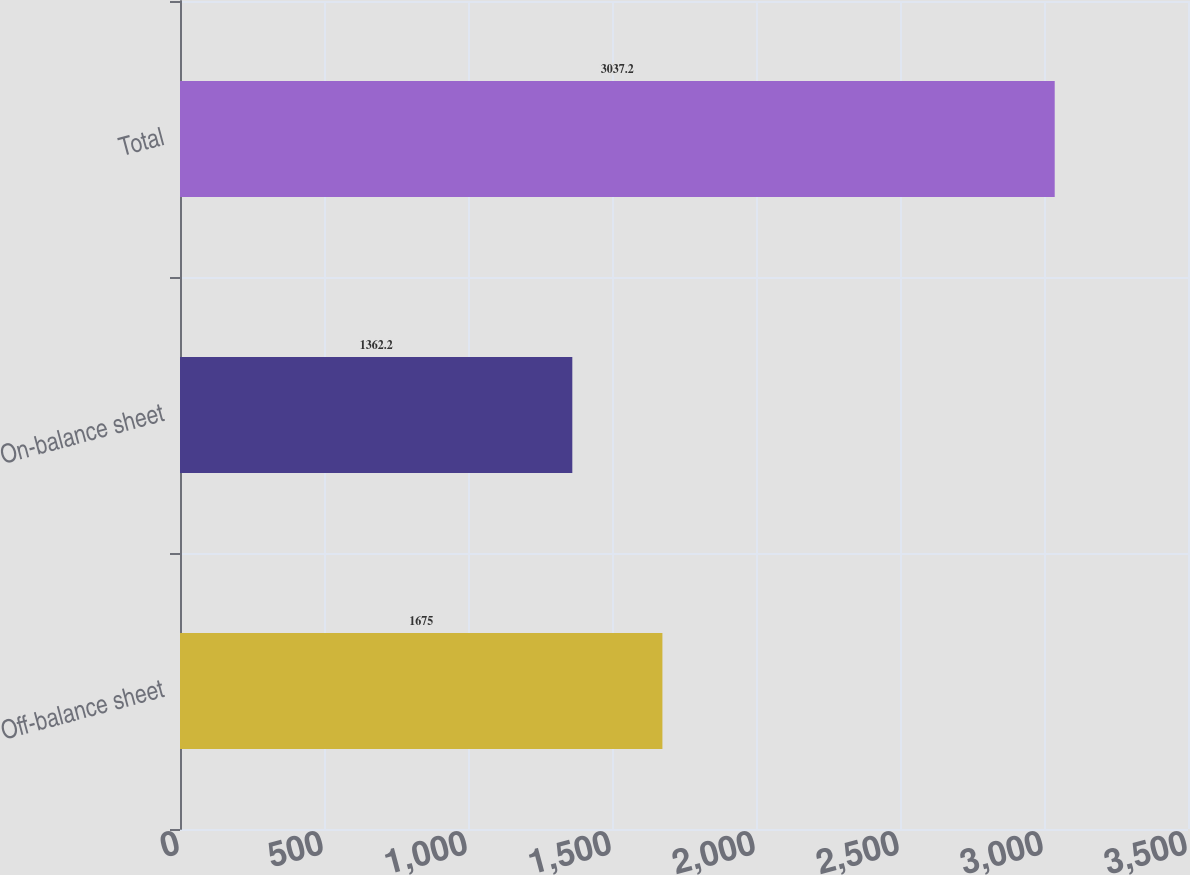<chart> <loc_0><loc_0><loc_500><loc_500><bar_chart><fcel>Off-balance sheet<fcel>On-balance sheet<fcel>Total<nl><fcel>1675<fcel>1362.2<fcel>3037.2<nl></chart> 